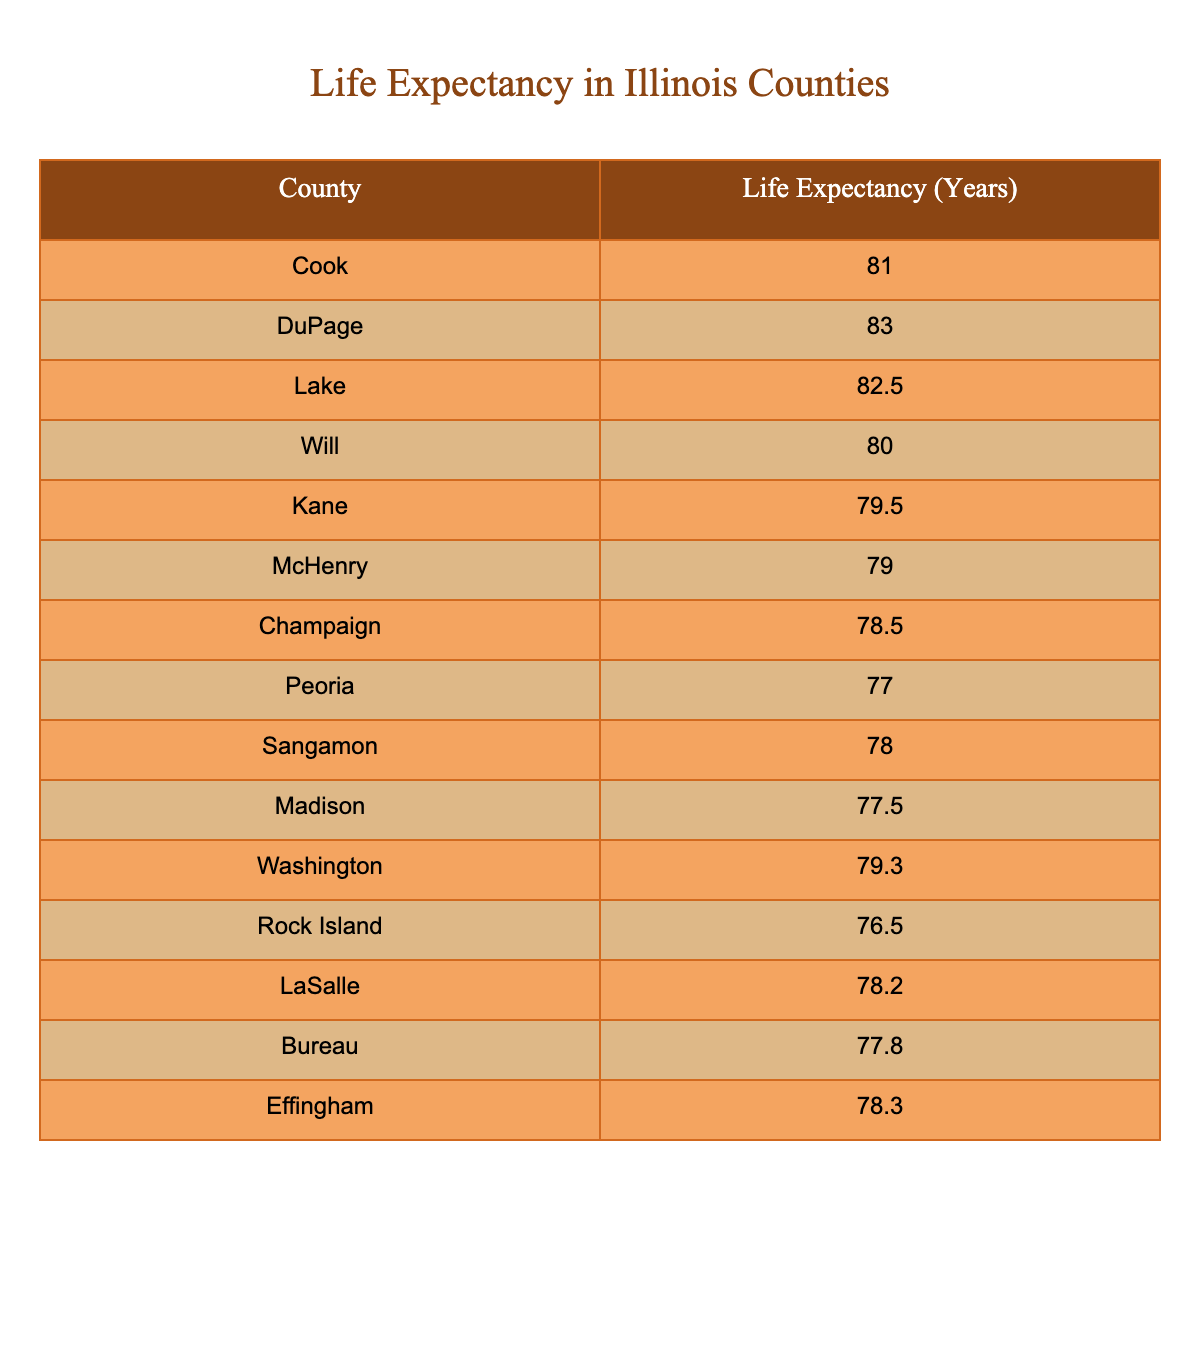What is the life expectancy in Cook County? Looking at the table, Cook County has a listed life expectancy of 81.0 years.
Answer: 81.0 Which county has the highest life expectancy? By examining the life expectancy values, DuPage County shows the highest at 83.0 years.
Answer: DuPage What is the difference in life expectancy between LaSalle and Peoria? LaSalle has a life expectancy of 78.2 years, while Peoria has 77.0 years. The difference is calculated as 78.2 - 77.0 = 1.2 years.
Answer: 1.2 Is the life expectancy in Madison County less than 78 years? The table shows that Madison County has a life expectancy of 77.5 years, which is less than 78 years.
Answer: Yes What is the average life expectancy of the counties listed? To find the average, we sum the life expectancies: (81.0 + 83.0 + 82.5 + 80.0 + 79.5 + 79.0 + 78.5 + 77.0 + 78.0 + 77.5 + 79.3 + 76.5 + 78.2 + 77.8 + 78.3) = 1176.6. There are 15 counties, so the average is 1176.6 / 15 = 78.44 years.
Answer: 78.44 How many counties have a life expectancy greater than 80 years? The counties with life expectancies over 80 years are Cook (81.0), DuPage (83.0), and Lake (82.5). That makes three counties in total.
Answer: 3 